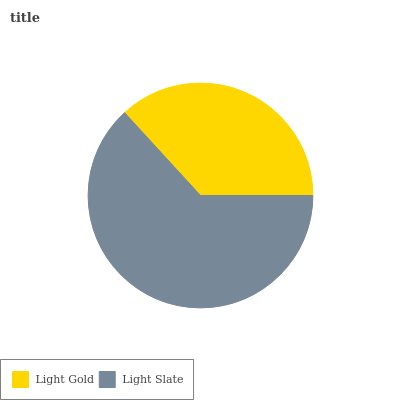Is Light Gold the minimum?
Answer yes or no. Yes. Is Light Slate the maximum?
Answer yes or no. Yes. Is Light Slate the minimum?
Answer yes or no. No. Is Light Slate greater than Light Gold?
Answer yes or no. Yes. Is Light Gold less than Light Slate?
Answer yes or no. Yes. Is Light Gold greater than Light Slate?
Answer yes or no. No. Is Light Slate less than Light Gold?
Answer yes or no. No. Is Light Slate the high median?
Answer yes or no. Yes. Is Light Gold the low median?
Answer yes or no. Yes. Is Light Gold the high median?
Answer yes or no. No. Is Light Slate the low median?
Answer yes or no. No. 